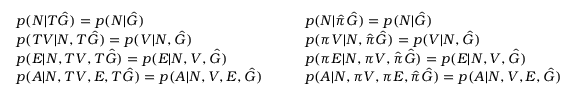Convert formula to latex. <formula><loc_0><loc_0><loc_500><loc_500>\begin{array} { r l r l } & { p ( N | T \hat { G } ) = p ( N | \hat { G } ) } & & { p ( N | \hat { \pi } \hat { G } ) = p ( N | \hat { G } ) } \\ & { p ( T V | N , T \hat { G } ) = p ( V | N , \hat { G } ) } & & { p ( \pi V | N , \hat { \pi } \hat { G } ) = p ( V | N , \hat { G } ) } \\ & { p ( E | N , T V , T \hat { G } ) = p ( E | N , V , \hat { G } ) } & & { p ( \pi E | N , \pi V , \hat { \pi } \hat { G } ) = p ( E | N , V , \hat { G } ) } \\ & { p ( A | N , T V , E , T \hat { G } ) = p ( A | N , V , E , \hat { G } ) \quad } & & { p ( A | N , \pi V , \pi E , \hat { \pi } \hat { G } ) = p ( A | N , V , E , \hat { G } ) } \end{array}</formula> 